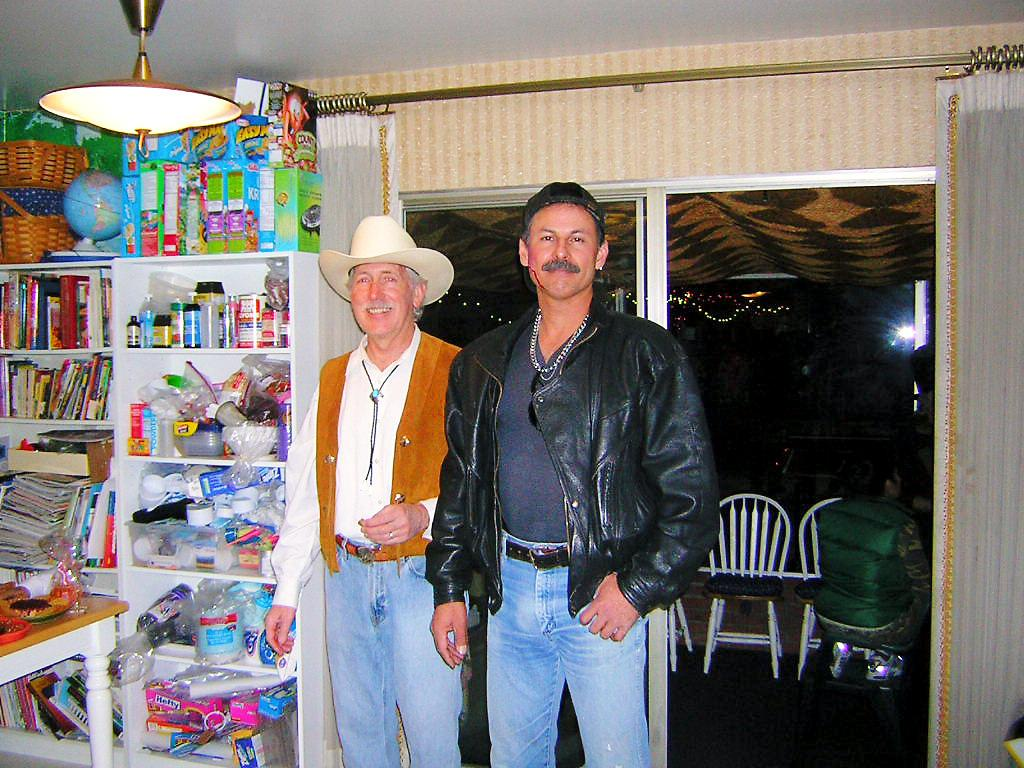How many people are present in the image? There are two men standing in the image. What is attached to the roof in the image? There is a light attached to the roof in the image. What can be seen in the background of the image? There is a window visible in the background of the image. What type of selection process is being conducted in the image? There is no indication of a selection process in the image; it simply shows two men standing and a light attached to the roof. How many cakes are being prepared in the image? There are no cakes present in the image. 